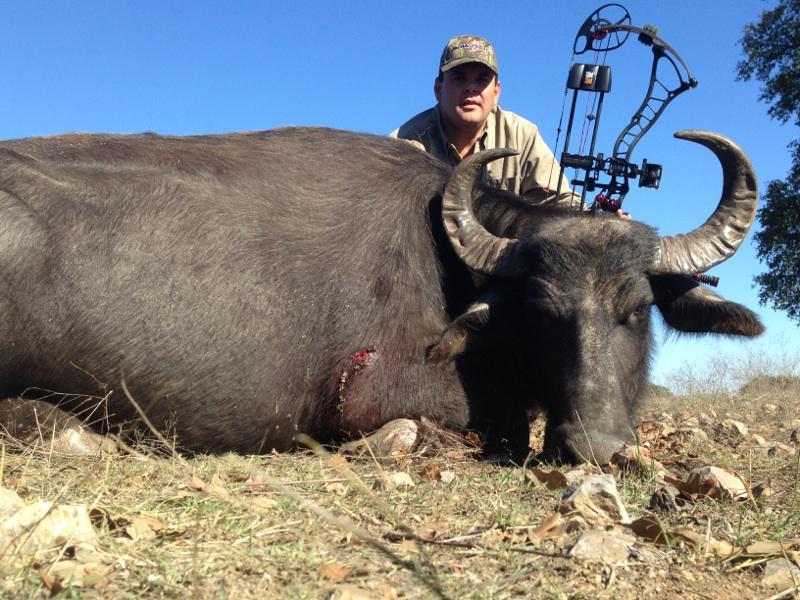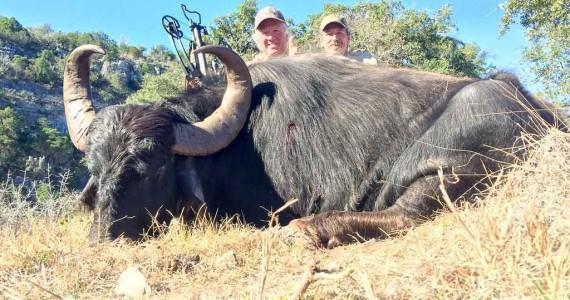The first image is the image on the left, the second image is the image on the right. For the images shown, is this caption "An animal is standing." true? Answer yes or no. No. The first image is the image on the left, the second image is the image on the right. Assess this claim about the two images: "The left and right image contains the same number of dead bulls.". Correct or not? Answer yes or no. Yes. 